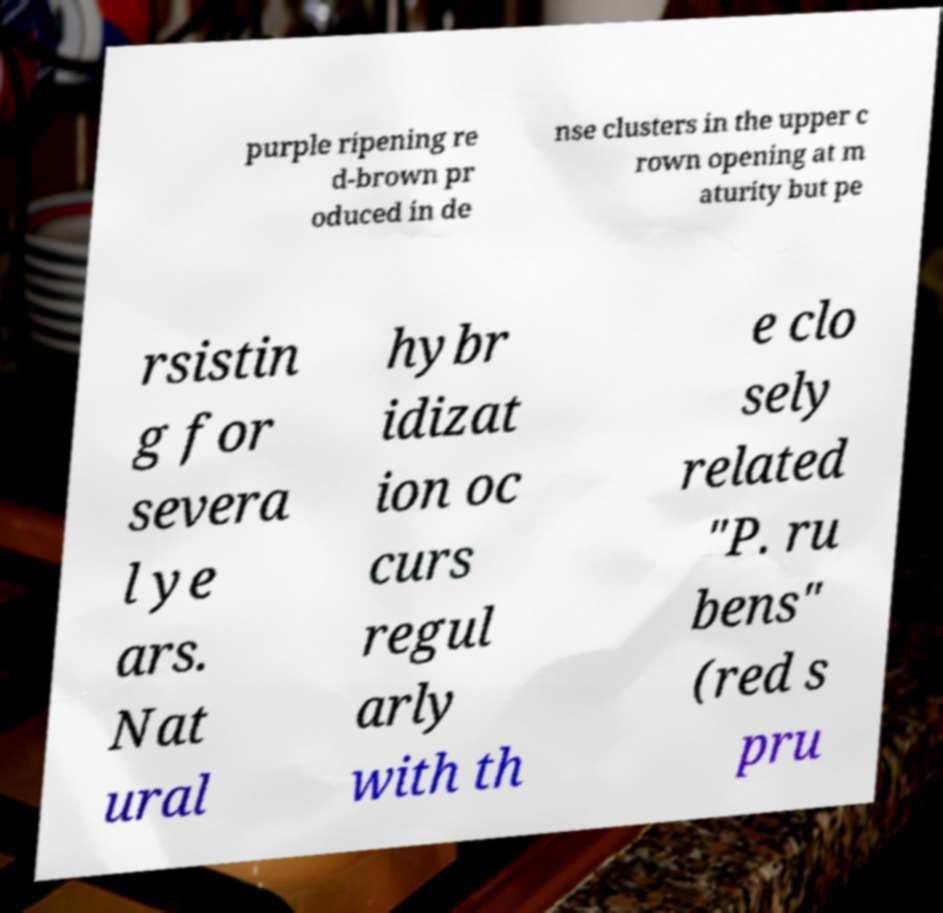For documentation purposes, I need the text within this image transcribed. Could you provide that? purple ripening re d-brown pr oduced in de nse clusters in the upper c rown opening at m aturity but pe rsistin g for severa l ye ars. Nat ural hybr idizat ion oc curs regul arly with th e clo sely related "P. ru bens" (red s pru 